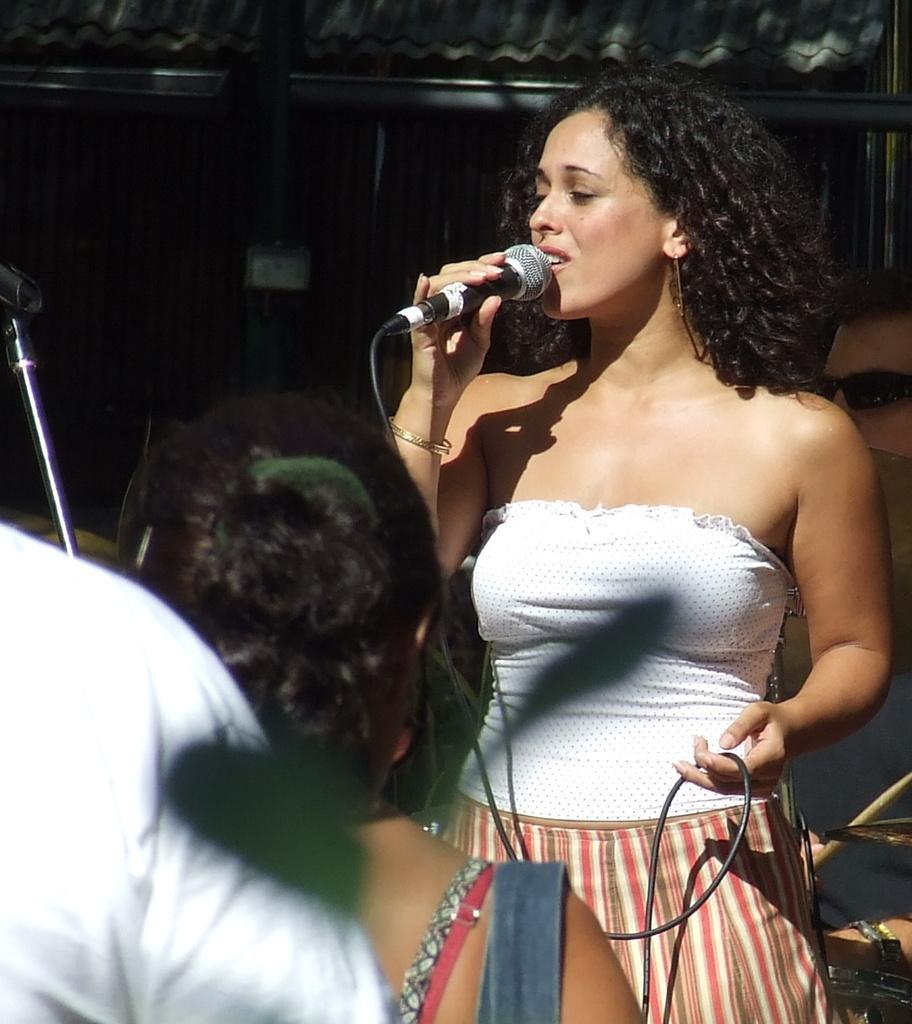In one or two sentences, can you explain what this image depicts? This woman holds mic and singing and she wore white t-shirt. These are audience. Far there is a shed. This is a musical plate. This man wore goggles. 